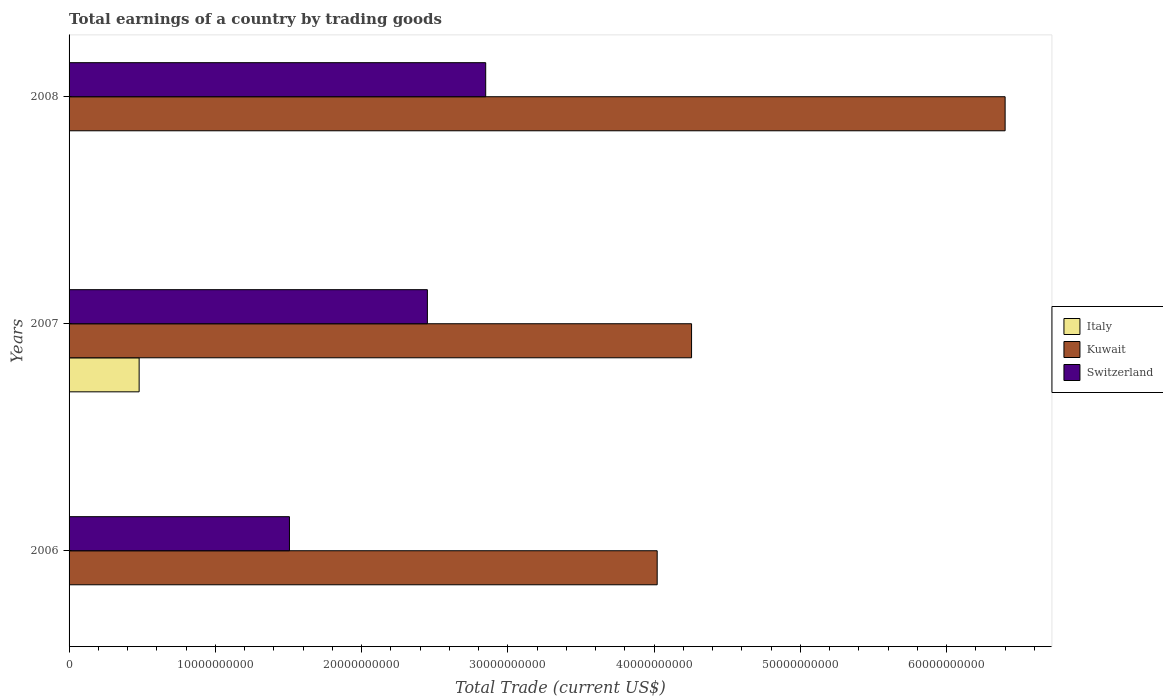How many groups of bars are there?
Your answer should be very brief. 3. How many bars are there on the 3rd tick from the bottom?
Offer a terse response. 2. In how many cases, is the number of bars for a given year not equal to the number of legend labels?
Give a very brief answer. 2. What is the total earnings in Switzerland in 2007?
Your response must be concise. 2.45e+1. Across all years, what is the maximum total earnings in Kuwait?
Your answer should be compact. 6.40e+1. What is the total total earnings in Kuwait in the graph?
Offer a very short reply. 1.47e+11. What is the difference between the total earnings in Kuwait in 2006 and that in 2008?
Your answer should be very brief. -2.38e+1. What is the difference between the total earnings in Italy in 2008 and the total earnings in Switzerland in 2007?
Offer a very short reply. -2.45e+1. What is the average total earnings in Kuwait per year?
Your answer should be compact. 4.89e+1. In the year 2007, what is the difference between the total earnings in Kuwait and total earnings in Switzerland?
Ensure brevity in your answer.  1.81e+1. In how many years, is the total earnings in Switzerland greater than 38000000000 US$?
Provide a succinct answer. 0. What is the ratio of the total earnings in Kuwait in 2007 to that in 2008?
Keep it short and to the point. 0.67. What is the difference between the highest and the second highest total earnings in Switzerland?
Offer a terse response. 3.99e+09. What is the difference between the highest and the lowest total earnings in Italy?
Offer a very short reply. 4.79e+09. Are all the bars in the graph horizontal?
Make the answer very short. Yes. How many years are there in the graph?
Your answer should be very brief. 3. Are the values on the major ticks of X-axis written in scientific E-notation?
Provide a short and direct response. No. Does the graph contain any zero values?
Your response must be concise. Yes. Does the graph contain grids?
Give a very brief answer. No. Where does the legend appear in the graph?
Keep it short and to the point. Center right. What is the title of the graph?
Ensure brevity in your answer.  Total earnings of a country by trading goods. Does "Guinea-Bissau" appear as one of the legend labels in the graph?
Give a very brief answer. No. What is the label or title of the X-axis?
Your response must be concise. Total Trade (current US$). What is the Total Trade (current US$) of Italy in 2006?
Give a very brief answer. 0. What is the Total Trade (current US$) of Kuwait in 2006?
Keep it short and to the point. 4.02e+1. What is the Total Trade (current US$) of Switzerland in 2006?
Make the answer very short. 1.51e+1. What is the Total Trade (current US$) of Italy in 2007?
Make the answer very short. 4.79e+09. What is the Total Trade (current US$) of Kuwait in 2007?
Offer a very short reply. 4.26e+1. What is the Total Trade (current US$) of Switzerland in 2007?
Offer a terse response. 2.45e+1. What is the Total Trade (current US$) in Kuwait in 2008?
Ensure brevity in your answer.  6.40e+1. What is the Total Trade (current US$) in Switzerland in 2008?
Your response must be concise. 2.85e+1. Across all years, what is the maximum Total Trade (current US$) of Italy?
Offer a terse response. 4.79e+09. Across all years, what is the maximum Total Trade (current US$) of Kuwait?
Provide a succinct answer. 6.40e+1. Across all years, what is the maximum Total Trade (current US$) in Switzerland?
Provide a short and direct response. 2.85e+1. Across all years, what is the minimum Total Trade (current US$) of Kuwait?
Your answer should be compact. 4.02e+1. Across all years, what is the minimum Total Trade (current US$) of Switzerland?
Provide a succinct answer. 1.51e+1. What is the total Total Trade (current US$) of Italy in the graph?
Your answer should be very brief. 4.79e+09. What is the total Total Trade (current US$) in Kuwait in the graph?
Ensure brevity in your answer.  1.47e+11. What is the total Total Trade (current US$) in Switzerland in the graph?
Keep it short and to the point. 6.81e+1. What is the difference between the Total Trade (current US$) in Kuwait in 2006 and that in 2007?
Keep it short and to the point. -2.35e+09. What is the difference between the Total Trade (current US$) in Switzerland in 2006 and that in 2007?
Offer a terse response. -9.43e+09. What is the difference between the Total Trade (current US$) of Kuwait in 2006 and that in 2008?
Ensure brevity in your answer.  -2.38e+1. What is the difference between the Total Trade (current US$) in Switzerland in 2006 and that in 2008?
Provide a short and direct response. -1.34e+1. What is the difference between the Total Trade (current US$) in Kuwait in 2007 and that in 2008?
Offer a terse response. -2.14e+1. What is the difference between the Total Trade (current US$) of Switzerland in 2007 and that in 2008?
Offer a terse response. -3.99e+09. What is the difference between the Total Trade (current US$) of Kuwait in 2006 and the Total Trade (current US$) of Switzerland in 2007?
Give a very brief answer. 1.57e+1. What is the difference between the Total Trade (current US$) in Kuwait in 2006 and the Total Trade (current US$) in Switzerland in 2008?
Keep it short and to the point. 1.17e+1. What is the difference between the Total Trade (current US$) in Italy in 2007 and the Total Trade (current US$) in Kuwait in 2008?
Provide a succinct answer. -5.92e+1. What is the difference between the Total Trade (current US$) in Italy in 2007 and the Total Trade (current US$) in Switzerland in 2008?
Keep it short and to the point. -2.37e+1. What is the difference between the Total Trade (current US$) in Kuwait in 2007 and the Total Trade (current US$) in Switzerland in 2008?
Ensure brevity in your answer.  1.41e+1. What is the average Total Trade (current US$) of Italy per year?
Make the answer very short. 1.60e+09. What is the average Total Trade (current US$) in Kuwait per year?
Ensure brevity in your answer.  4.89e+1. What is the average Total Trade (current US$) in Switzerland per year?
Your answer should be very brief. 2.27e+1. In the year 2006, what is the difference between the Total Trade (current US$) of Kuwait and Total Trade (current US$) of Switzerland?
Provide a short and direct response. 2.51e+1. In the year 2007, what is the difference between the Total Trade (current US$) in Italy and Total Trade (current US$) in Kuwait?
Your response must be concise. -3.78e+1. In the year 2007, what is the difference between the Total Trade (current US$) of Italy and Total Trade (current US$) of Switzerland?
Ensure brevity in your answer.  -1.97e+1. In the year 2007, what is the difference between the Total Trade (current US$) in Kuwait and Total Trade (current US$) in Switzerland?
Provide a succinct answer. 1.81e+1. In the year 2008, what is the difference between the Total Trade (current US$) of Kuwait and Total Trade (current US$) of Switzerland?
Keep it short and to the point. 3.55e+1. What is the ratio of the Total Trade (current US$) in Kuwait in 2006 to that in 2007?
Your answer should be very brief. 0.94. What is the ratio of the Total Trade (current US$) of Switzerland in 2006 to that in 2007?
Give a very brief answer. 0.61. What is the ratio of the Total Trade (current US$) of Kuwait in 2006 to that in 2008?
Give a very brief answer. 0.63. What is the ratio of the Total Trade (current US$) in Switzerland in 2006 to that in 2008?
Make the answer very short. 0.53. What is the ratio of the Total Trade (current US$) in Kuwait in 2007 to that in 2008?
Provide a succinct answer. 0.67. What is the ratio of the Total Trade (current US$) in Switzerland in 2007 to that in 2008?
Keep it short and to the point. 0.86. What is the difference between the highest and the second highest Total Trade (current US$) of Kuwait?
Offer a terse response. 2.14e+1. What is the difference between the highest and the second highest Total Trade (current US$) in Switzerland?
Provide a succinct answer. 3.99e+09. What is the difference between the highest and the lowest Total Trade (current US$) of Italy?
Provide a short and direct response. 4.79e+09. What is the difference between the highest and the lowest Total Trade (current US$) in Kuwait?
Your answer should be compact. 2.38e+1. What is the difference between the highest and the lowest Total Trade (current US$) in Switzerland?
Ensure brevity in your answer.  1.34e+1. 